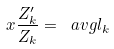<formula> <loc_0><loc_0><loc_500><loc_500>x \frac { Z _ { k } ^ { \prime } } { Z _ { k } } = \ a v g { l } _ { k }</formula> 